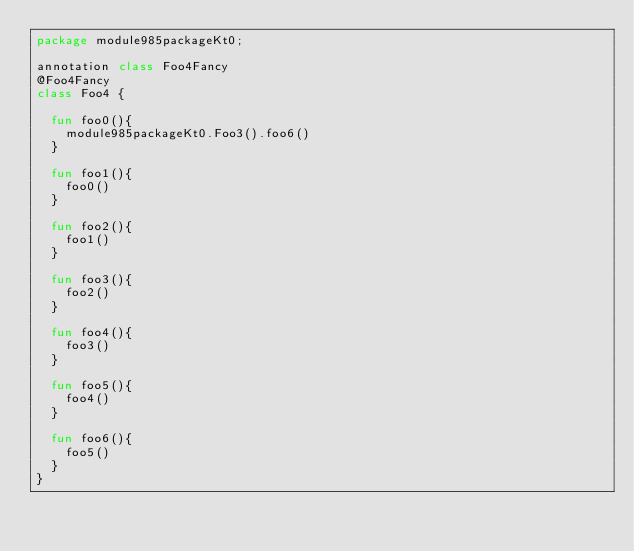Convert code to text. <code><loc_0><loc_0><loc_500><loc_500><_Kotlin_>package module985packageKt0;

annotation class Foo4Fancy
@Foo4Fancy
class Foo4 {

  fun foo0(){
    module985packageKt0.Foo3().foo6()
  }

  fun foo1(){
    foo0()
  }

  fun foo2(){
    foo1()
  }

  fun foo3(){
    foo2()
  }

  fun foo4(){
    foo3()
  }

  fun foo5(){
    foo4()
  }

  fun foo6(){
    foo5()
  }
}</code> 